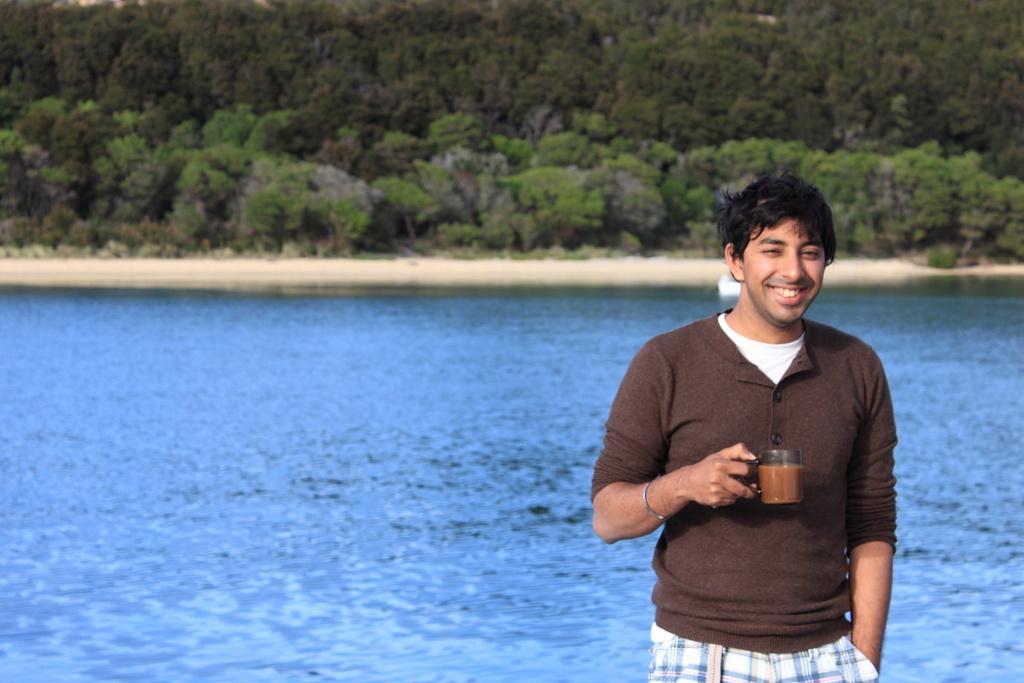How would you summarize this image in a sentence or two? In this picture we can see a man and he is holding a cup with drink in it and in the background we can see water and trees. 